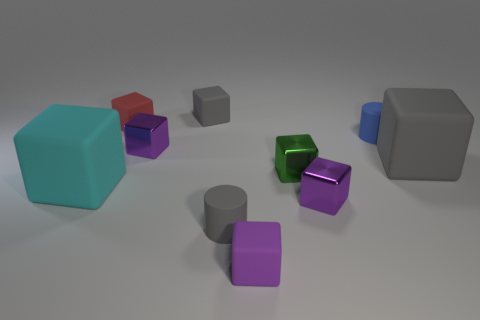How many purple blocks must be subtracted to get 1 purple blocks? 2 Subtract all green balls. How many purple cubes are left? 3 Subtract all small red rubber blocks. How many blocks are left? 7 Subtract all red blocks. How many blocks are left? 7 Subtract 4 blocks. How many blocks are left? 4 Subtract all brown blocks. Subtract all green balls. How many blocks are left? 8 Subtract all cylinders. How many objects are left? 8 Add 1 big rubber objects. How many big rubber objects are left? 3 Add 7 large matte blocks. How many large matte blocks exist? 9 Subtract 0 yellow blocks. How many objects are left? 10 